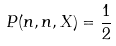<formula> <loc_0><loc_0><loc_500><loc_500>P ( n , n , X ) = \frac { 1 } { 2 }</formula> 